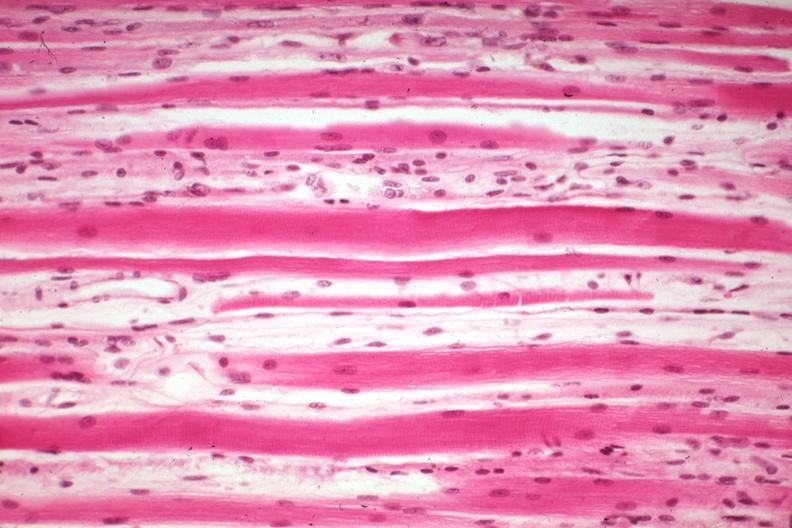what is present?
Answer the question using a single word or phrase. Soft tissue 